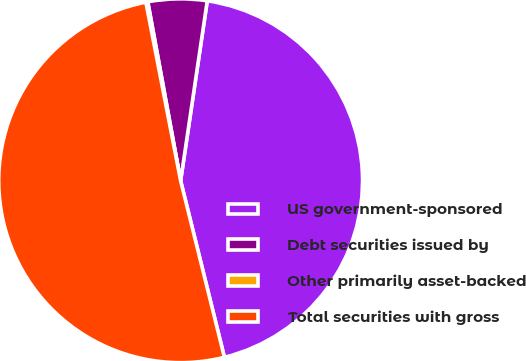Convert chart to OTSL. <chart><loc_0><loc_0><loc_500><loc_500><pie_chart><fcel>US government-sponsored<fcel>Debt securities issued by<fcel>Other primarily asset-backed<fcel>Total securities with gross<nl><fcel>43.79%<fcel>5.23%<fcel>0.17%<fcel>50.81%<nl></chart> 